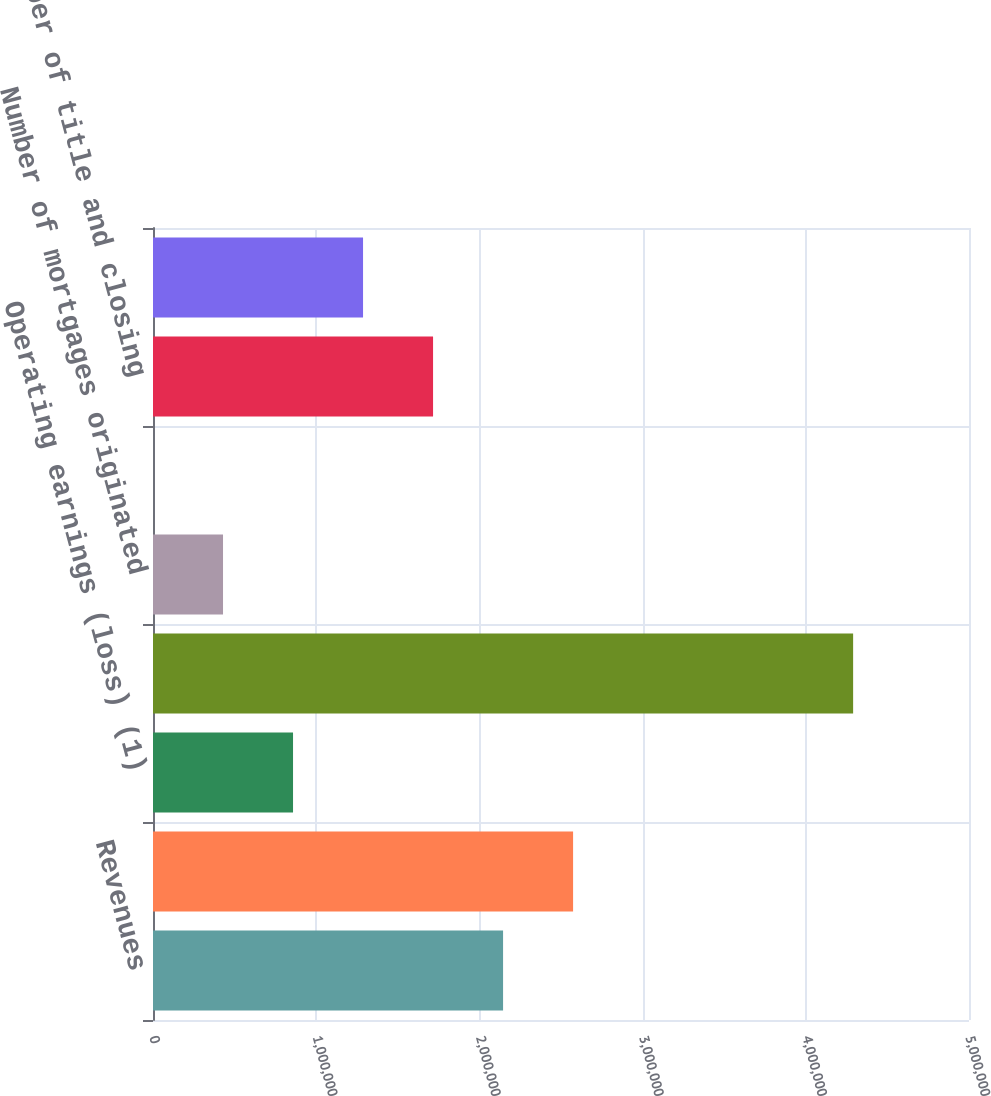<chart> <loc_0><loc_0><loc_500><loc_500><bar_chart><fcel>Revenues<fcel>Costs and expenses (1)<fcel>Operating earnings (loss) (1)<fcel>Dollar value of mortgages<fcel>Number of mortgages originated<fcel>Mortgage capture rate of<fcel>Number of title and closing<fcel>Number of title policies<nl><fcel>2.14504e+06<fcel>2.57403e+06<fcel>858068<fcel>4.29e+06<fcel>429076<fcel>85<fcel>1.71605e+06<fcel>1.28706e+06<nl></chart> 